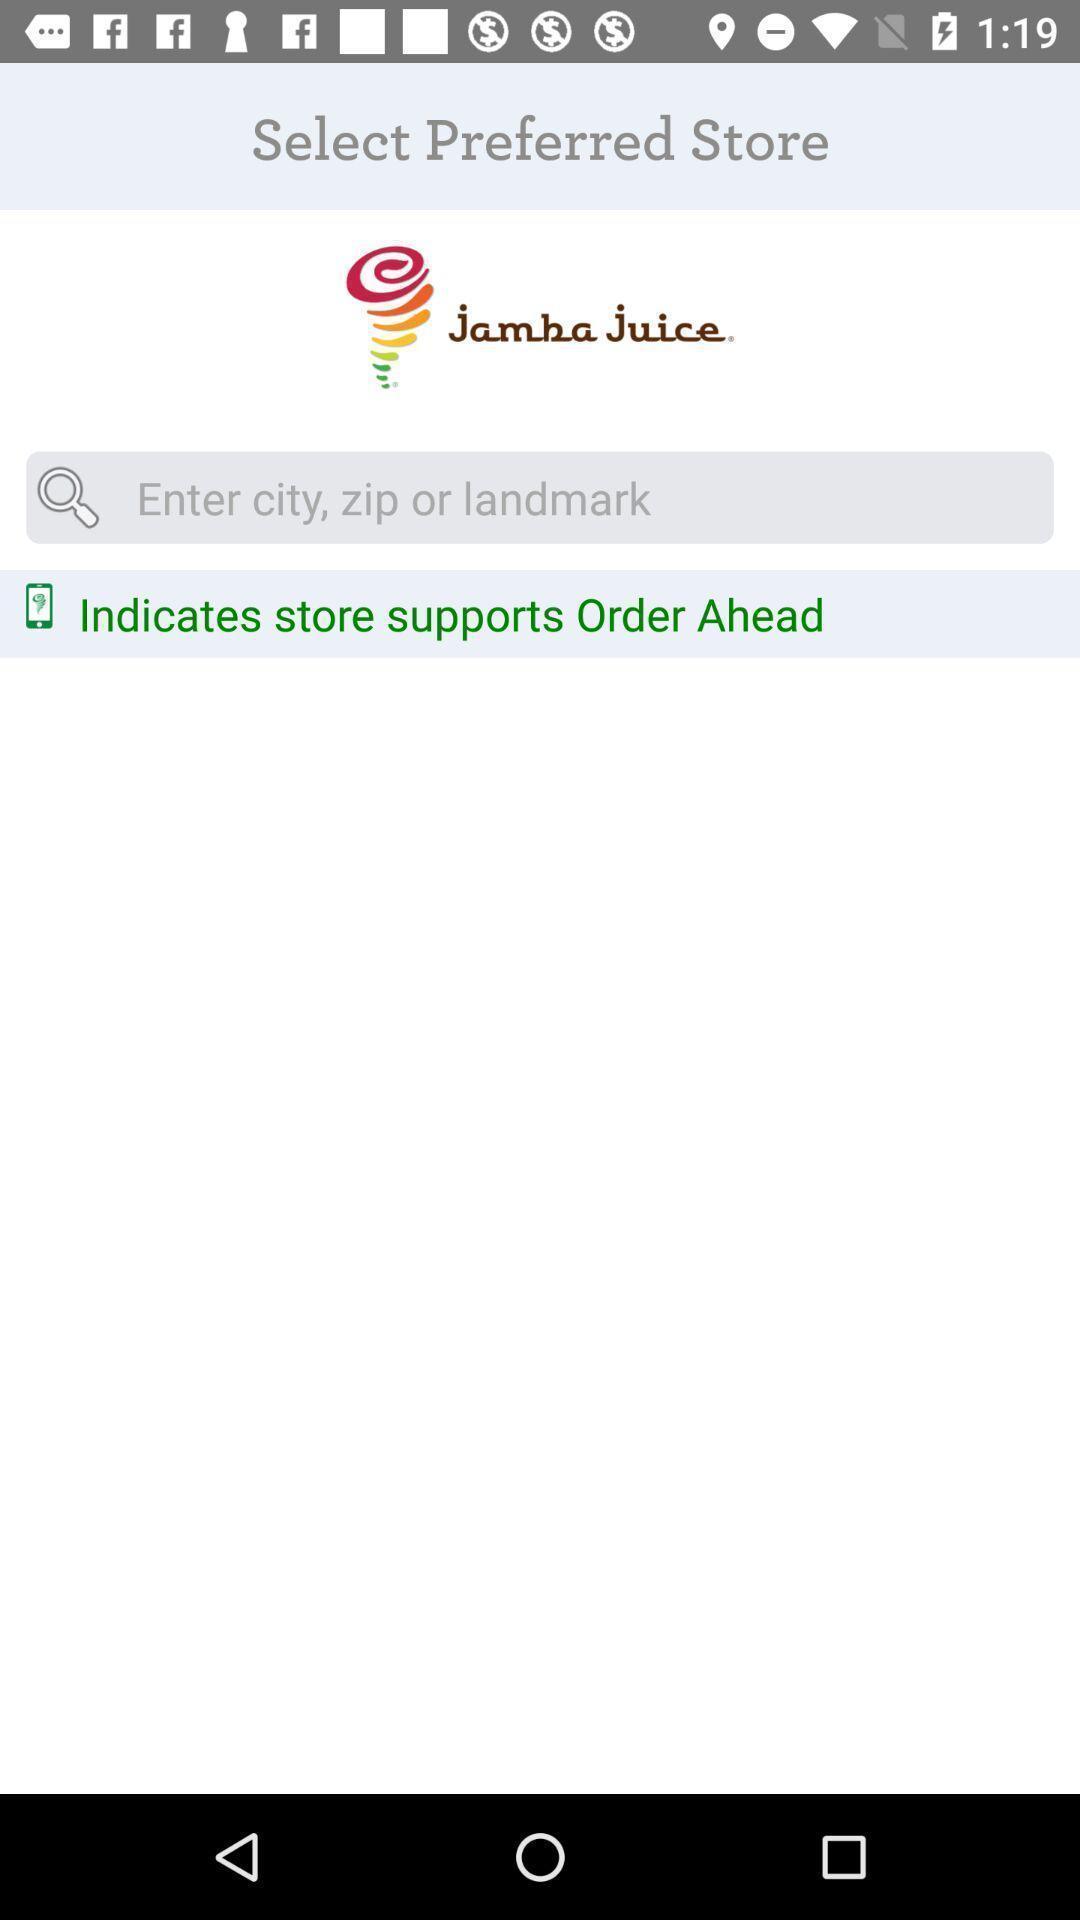Describe the content in this image. Search page for finding selected store on shopping app. 